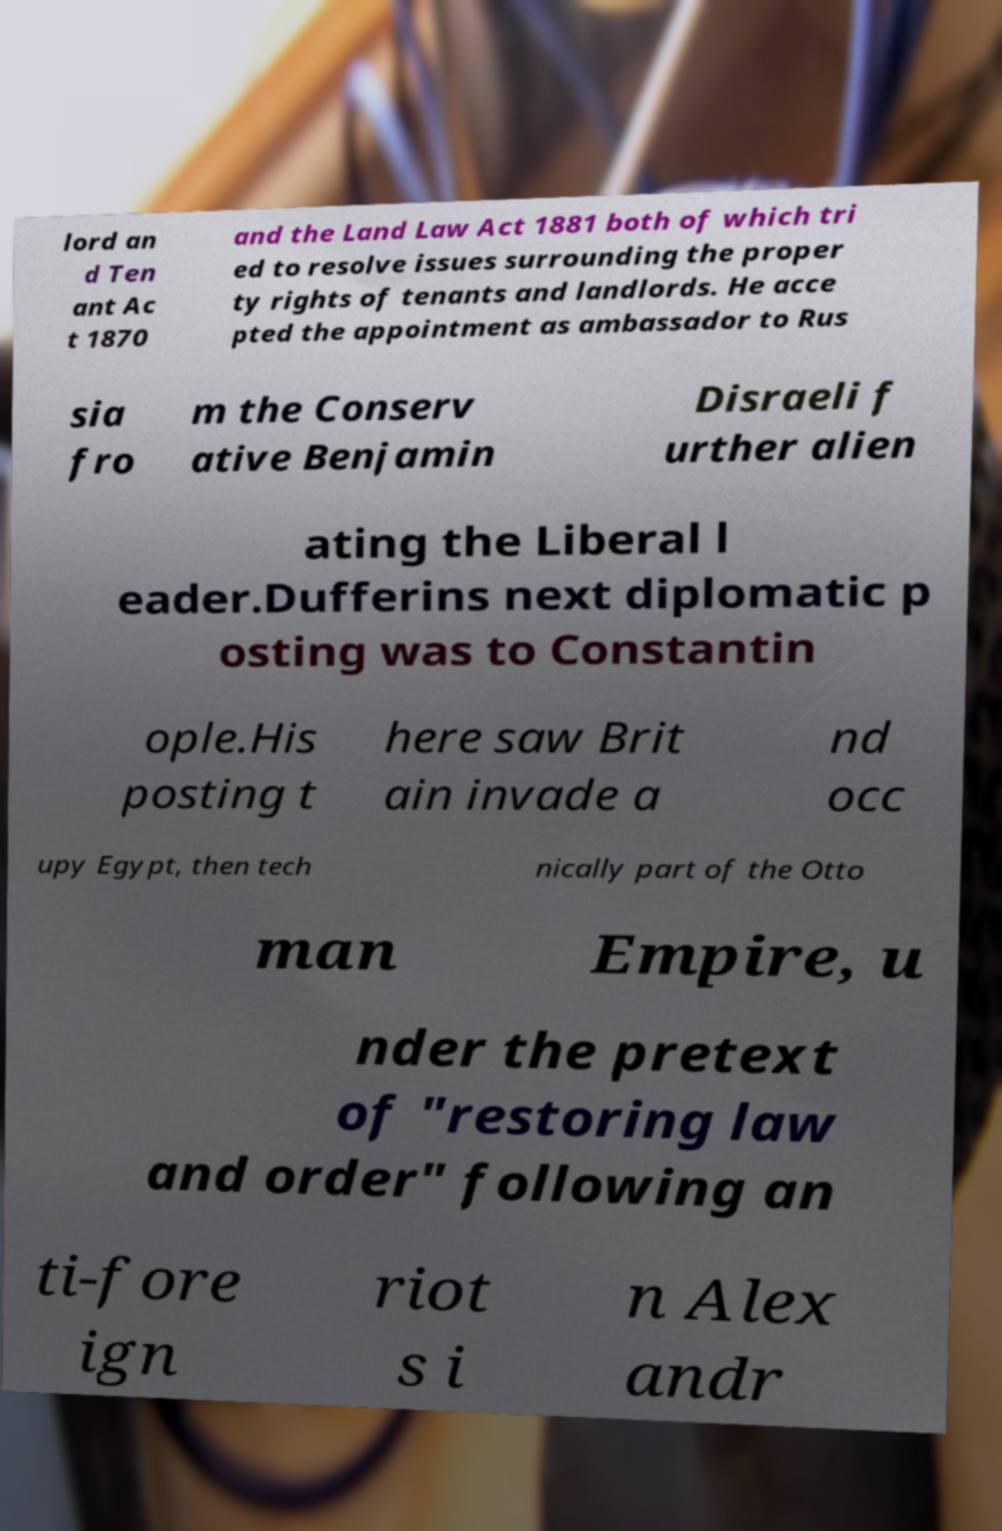Could you extract and type out the text from this image? lord an d Ten ant Ac t 1870 and the Land Law Act 1881 both of which tri ed to resolve issues surrounding the proper ty rights of tenants and landlords. He acce pted the appointment as ambassador to Rus sia fro m the Conserv ative Benjamin Disraeli f urther alien ating the Liberal l eader.Dufferins next diplomatic p osting was to Constantin ople.His posting t here saw Brit ain invade a nd occ upy Egypt, then tech nically part of the Otto man Empire, u nder the pretext of "restoring law and order" following an ti-fore ign riot s i n Alex andr 